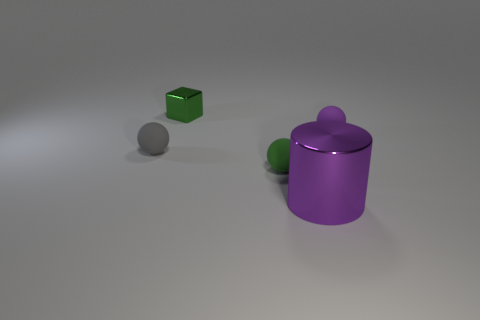There is a shiny object that is the same size as the green matte sphere; what color is it?
Your answer should be very brief. Green. There is a thing that is right of the green metal thing and to the left of the big purple shiny object; what is its shape?
Your answer should be very brief. Sphere. There is a rubber thing on the left side of the metal thing on the left side of the cylinder; how big is it?
Offer a very short reply. Small. What number of metal cylinders have the same color as the small metallic cube?
Your answer should be very brief. 0. What number of other objects are there of the same size as the green ball?
Provide a succinct answer. 3. What is the size of the rubber thing that is both on the right side of the block and in front of the purple matte thing?
Your response must be concise. Small. What number of other small purple rubber things have the same shape as the purple matte object?
Provide a succinct answer. 0. What is the material of the tiny gray thing?
Offer a very short reply. Rubber. Is the shape of the tiny green metal thing the same as the tiny gray matte object?
Your answer should be very brief. No. Are there any big purple things that have the same material as the purple cylinder?
Your response must be concise. No. 